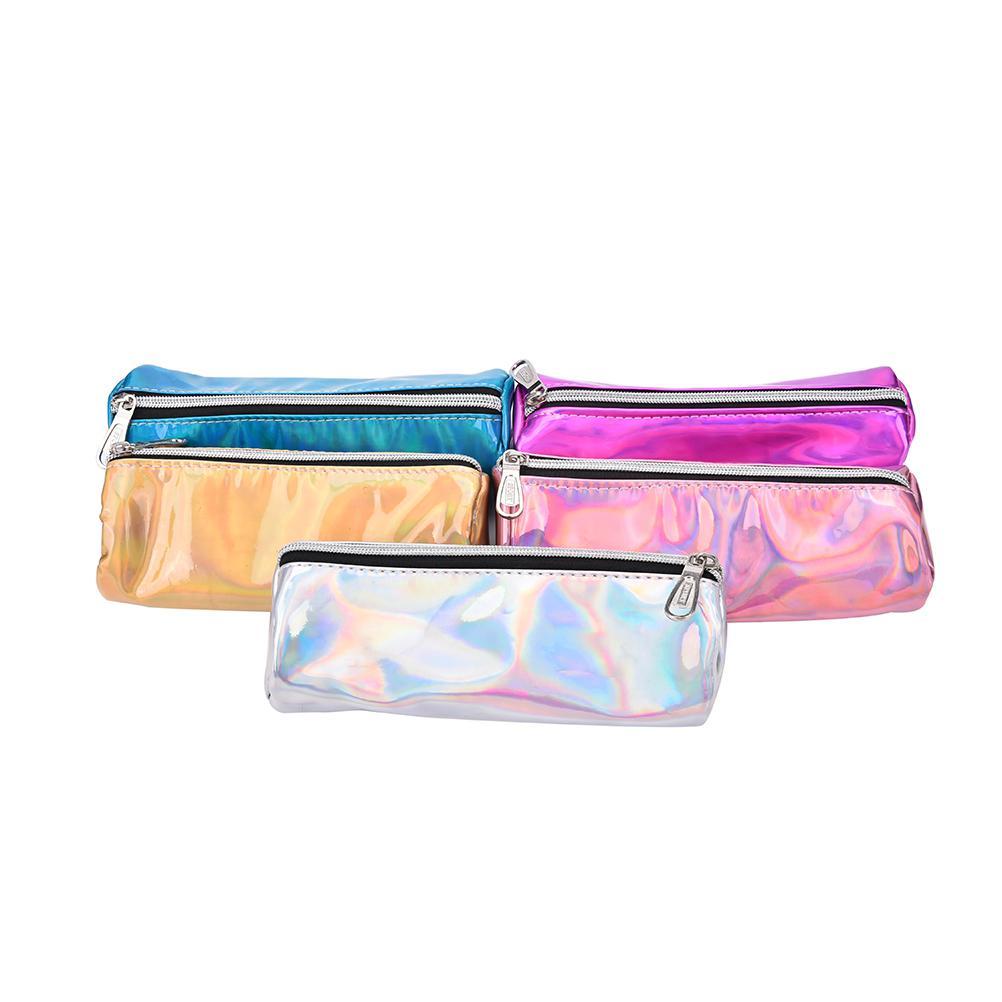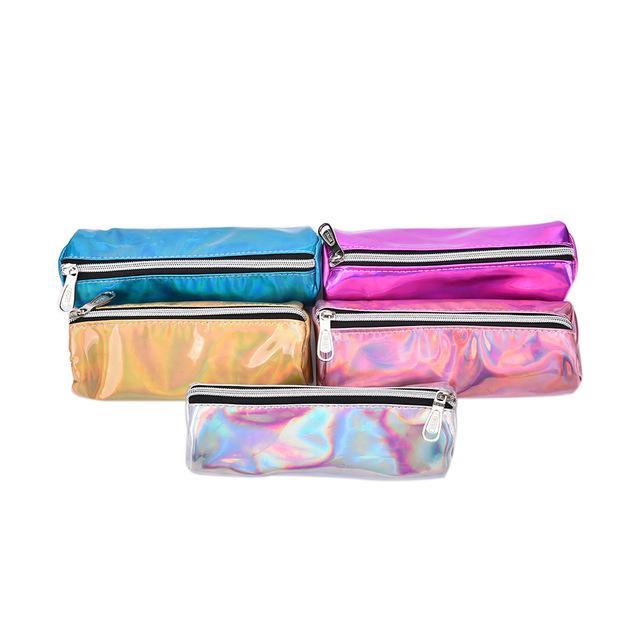The first image is the image on the left, the second image is the image on the right. Considering the images on both sides, is "The pair of images contain nearly identical items, with the same colors." valid? Answer yes or no. Yes. 